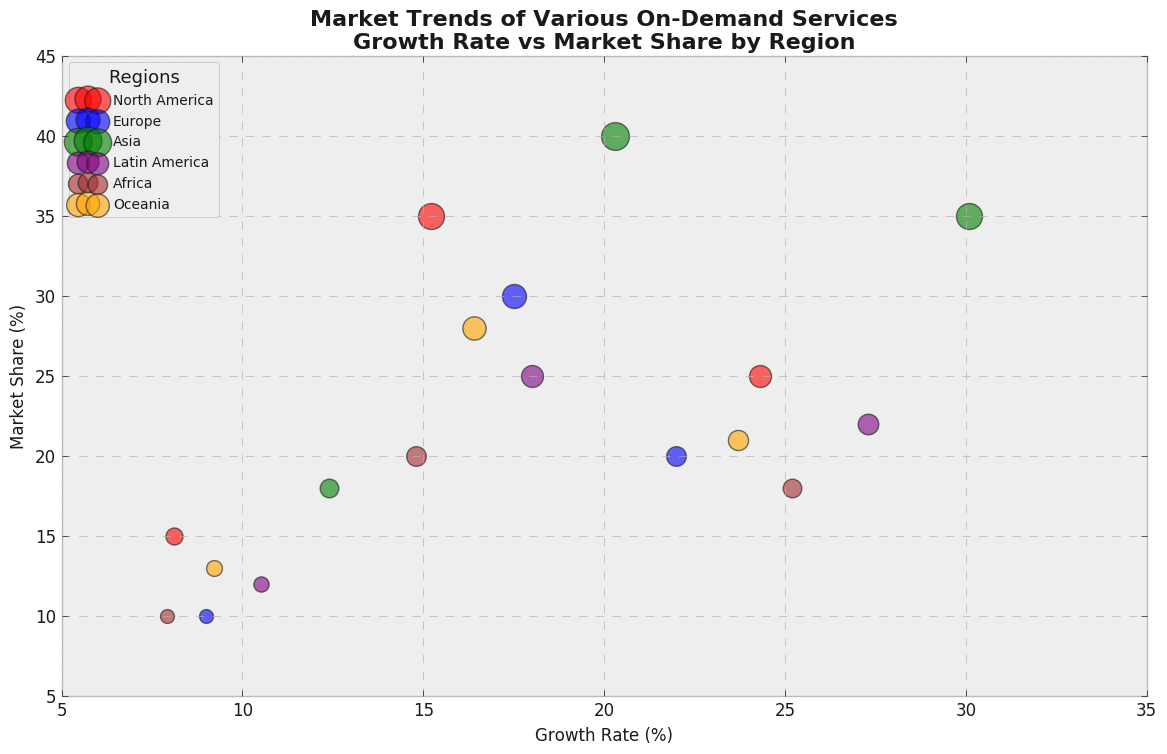Which service shows the highest growth rate in North America? Look at the bubbles labeled for North America. The Food Delivery service has the highest growth rate with a growth rate of 24.3%.
Answer: Food Delivery Which region has the largest market share for Ride Hailing services? Identify the bubbles associated with Ride Hailing and compare their market shares. Asia shows the largest market share for Ride Hailing services, with a market share of 40%.
Answer: Asia What’s the combined market share for Home Cleaning services across all regions? Add the market shares for Home Cleaning in each region. North America (15), Europe (10), Asia (18), Latin America (12), Africa (10), Oceania (13). The combined market share is 15 + 10 + 18 + 12 + 10 + 13 = 78%.
Answer: 78% Which region shows the smallest bubble for Home Cleaning services and what is this bubble's size? Identify the smallest bubble by comparing the sizes visually. Africa has the smallest bubble for Home Cleaning services, with a market share of 10% (size is based on market share).
Answer: Africa, 10% Between Europe and Latin America, which has a higher growth rate for Food Delivery services? Compare the growth rate for Food Delivery in Europe and Latin America. Europe has 22.0% while Latin America has 27.3%. Latin America has a higher growth rate.
Answer: Latin America Which service in Asia has the lowest growth rate and what is the rate? Identify and compare the growth rates of different services in Asia. Home Cleaning has the lowest growth rate in Asia at 12.4%.
Answer: Home Cleaning, 12.4% How does the market share of Food Delivery in Oceania compare to North America? Compare the market share visually. Food Delivery has a market share of 21% in Oceania and 25% in North America. Thus, North America's market share is greater.
Answer: North America is higher What is the average growth rate for Food Delivery services across all regions? Calculate the mean of Food Delivery growth rates in all regions. (24.3 + 22.0 + 30.1 + 27.3 + 25.2 + 23.7) / 6 = 152.6 / 6 = ~25.43%.
Answer: ~25.43% How many regions have Ride Hailing services with growth rates above 16%? Identify and count the regions where Ride Hailing has a growth rate greater than 16%. Europe (17.5%), Asia (20.3%), Latin America (18.0%), and Oceania (16.4%) all meet this criterion, totaling 4 regions.
Answer: 4 regions What is the difference in market share between Food Delivery and Home Cleaning services in Asia? Subtract the market share of Home Cleaning from Food Delivery in Asia. Food Delivery (35%) - Home Cleaning (18%) = 17%.
Answer: 17% 